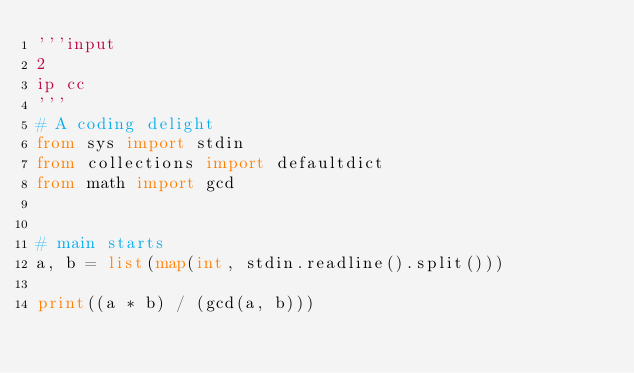Convert code to text. <code><loc_0><loc_0><loc_500><loc_500><_Python_>'''input
2
ip cc
'''
# A coding delight
from sys import stdin
from collections import defaultdict
from math import gcd


# main starts
a, b = list(map(int, stdin.readline().split()))

print((a * b) / (gcd(a, b)))</code> 